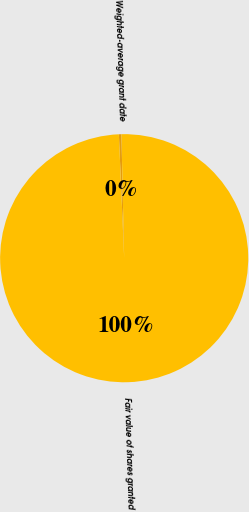Convert chart to OTSL. <chart><loc_0><loc_0><loc_500><loc_500><pie_chart><fcel>Weighted-average grant date<fcel>Fair value of shares granted<nl><fcel>0.33%<fcel>99.67%<nl></chart> 